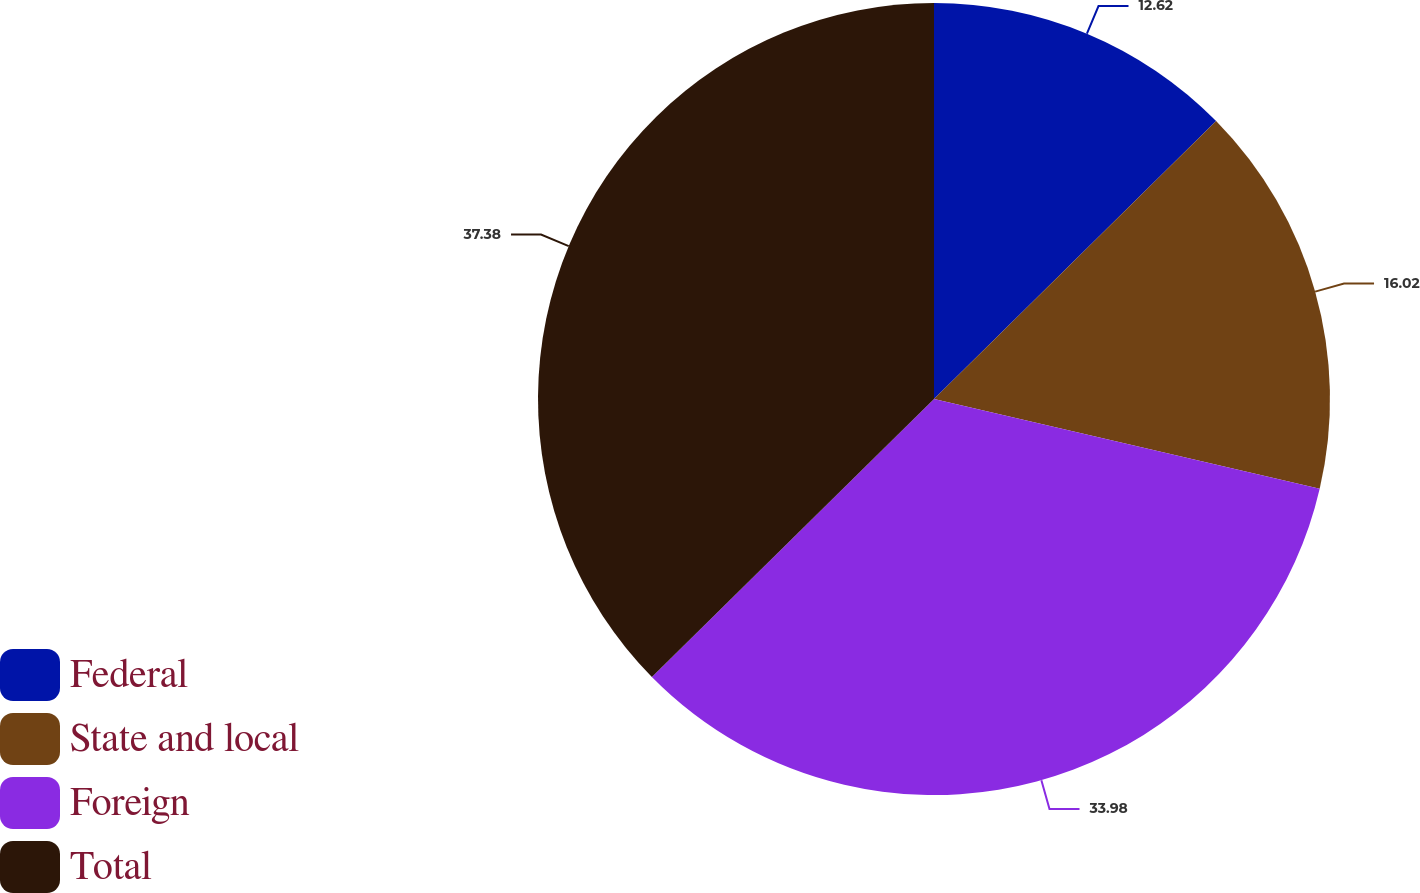Convert chart. <chart><loc_0><loc_0><loc_500><loc_500><pie_chart><fcel>Federal<fcel>State and local<fcel>Foreign<fcel>Total<nl><fcel>12.62%<fcel>16.02%<fcel>33.98%<fcel>37.38%<nl></chart> 